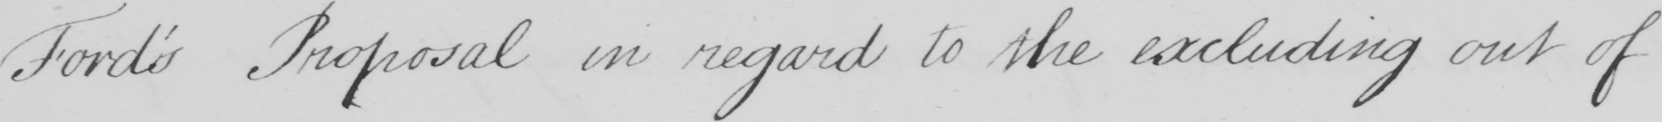What does this handwritten line say? Ford ' s Proposal in regard to the excluding out of 